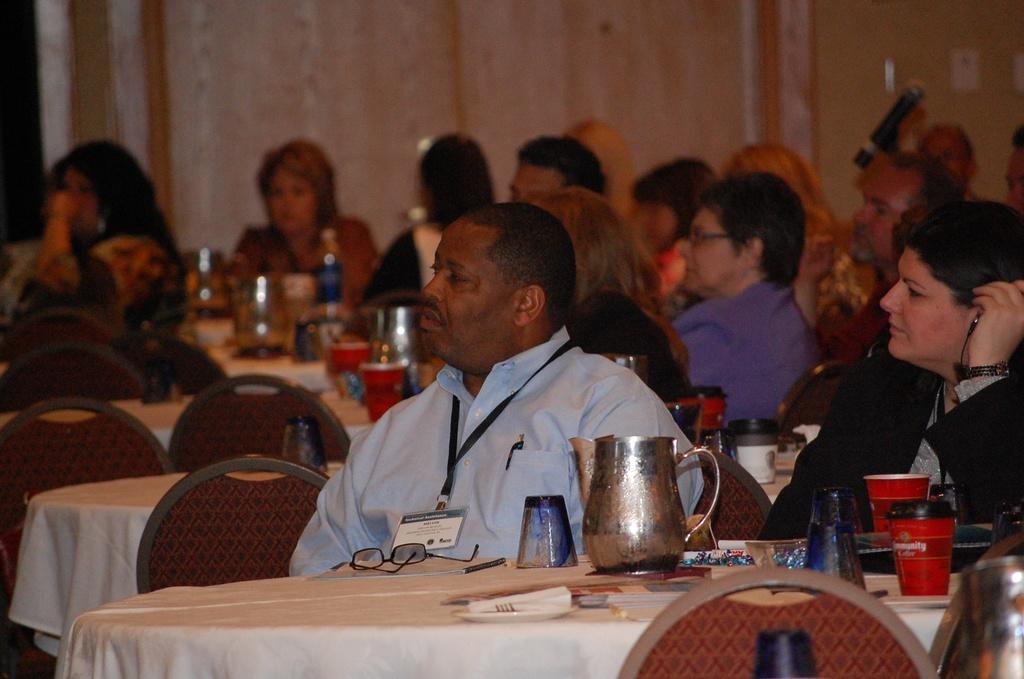Describe this image in one or two sentences. In this picture there are group of people sitting on the chairs and there are tables and chairs. There are mugs, glasses, cups, saucers and there are objects on the table and the tables are covered with white color clothes. At the back there is a door and there is a wall. 